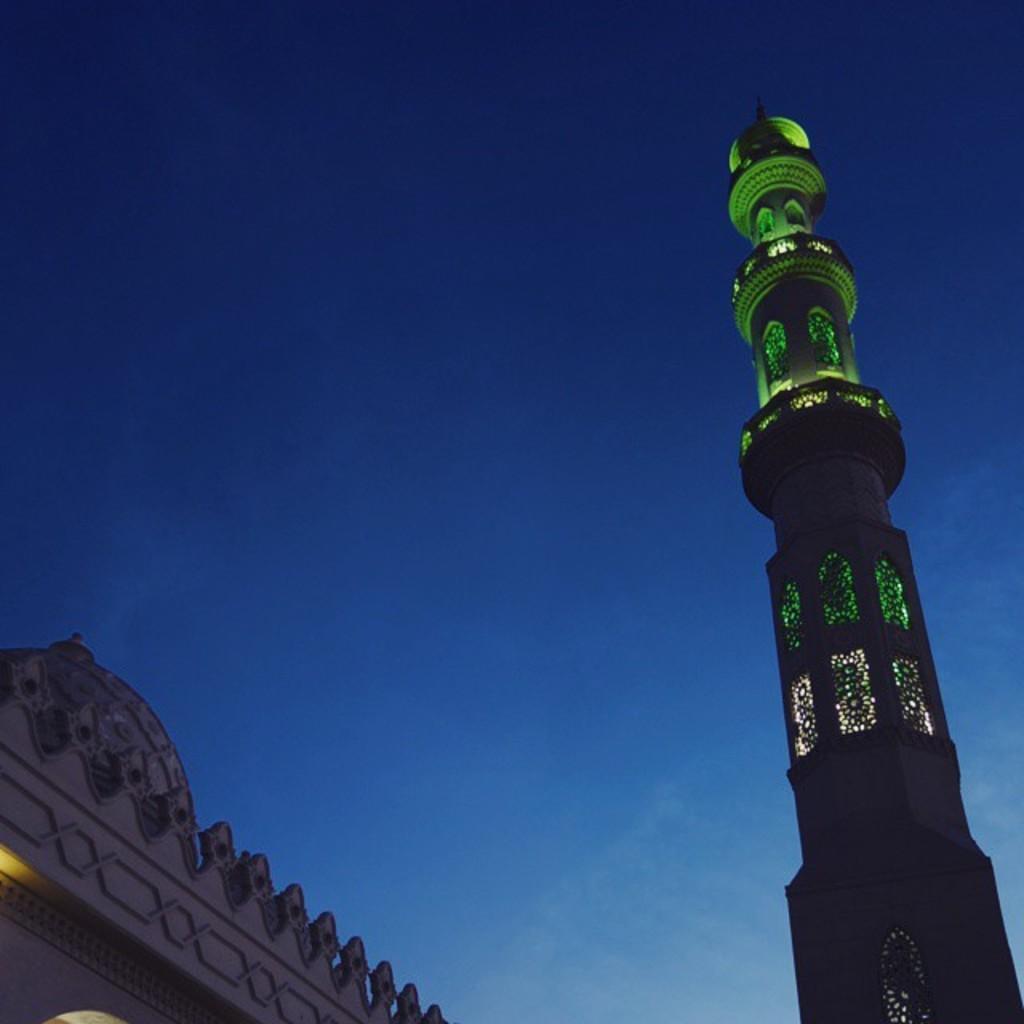Please provide a concise description of this image. In the picture we can see a mosque and a Minor with a green light focus to it and in the background, we can see a sky which is blue in color. 